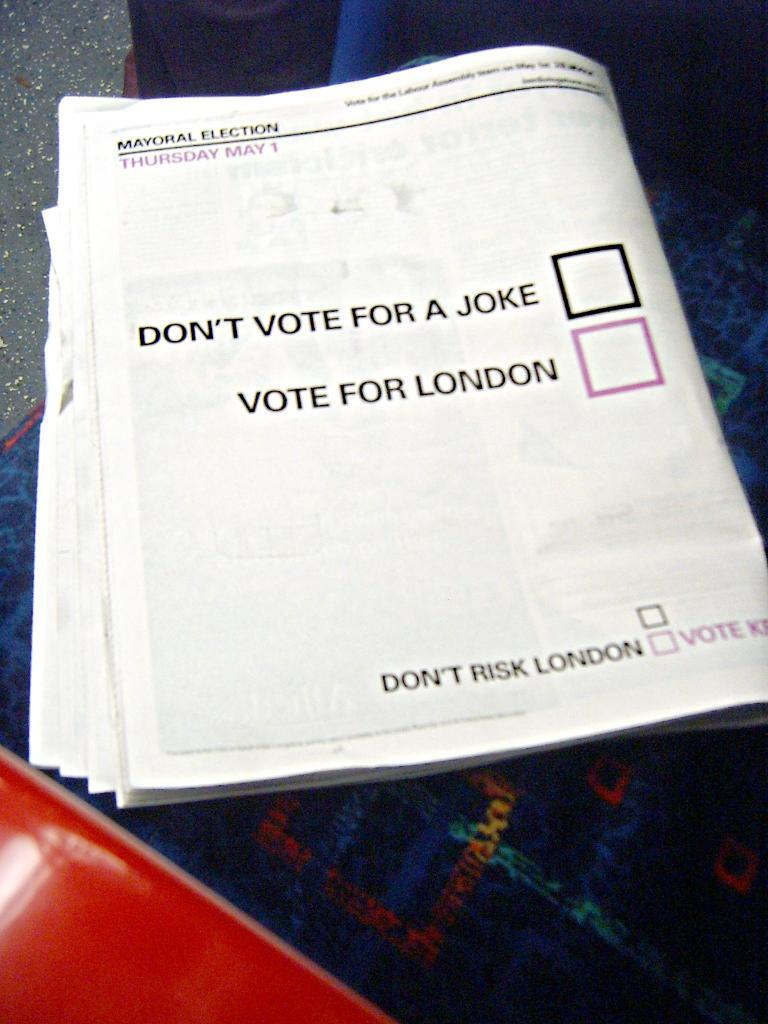<image>
Describe the image concisely. The catalog shows an option to vote for London. 